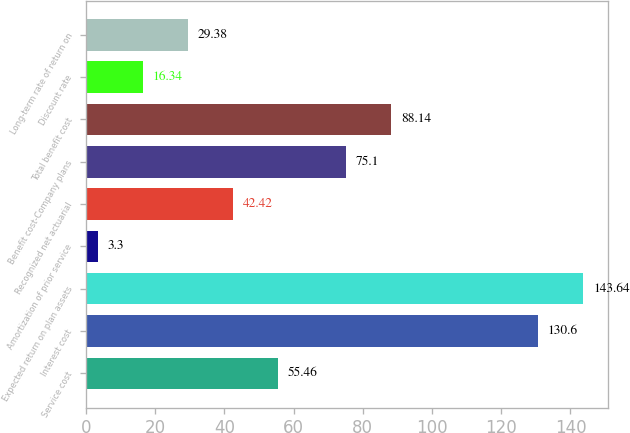Convert chart to OTSL. <chart><loc_0><loc_0><loc_500><loc_500><bar_chart><fcel>Service cost<fcel>Interest cost<fcel>Expected return on plan assets<fcel>Amortization of prior service<fcel>Recognized net actuarial<fcel>Benefit cost-Company plans<fcel>Total benefit cost<fcel>Discount rate<fcel>Long-term rate of return on<nl><fcel>55.46<fcel>130.6<fcel>143.64<fcel>3.3<fcel>42.42<fcel>75.1<fcel>88.14<fcel>16.34<fcel>29.38<nl></chart> 